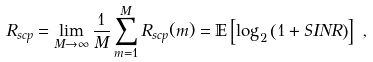<formula> <loc_0><loc_0><loc_500><loc_500>R _ { s c p } & = \lim _ { M \rightarrow \infty } \frac { 1 } { M } \sum _ { m = 1 } ^ { M } R _ { s c p } ( m ) = { \mathbb { E } } \left [ \log _ { 2 } \left ( 1 + S I N R \right ) \right ] \ ,</formula> 